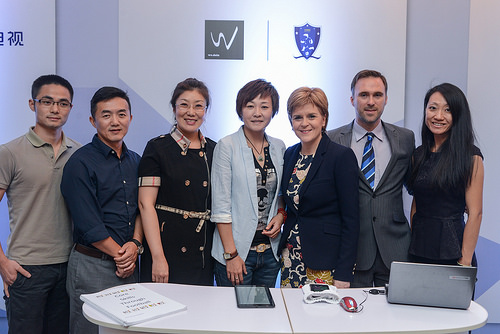<image>
Is there a women behind the table? Yes. From this viewpoint, the women is positioned behind the table, with the table partially or fully occluding the women. Where is the woman in relation to the man? Is it behind the man? No. The woman is not behind the man. From this viewpoint, the woman appears to be positioned elsewhere in the scene. Where is the laptop in relation to the wall? Is it on the wall? No. The laptop is not positioned on the wall. They may be near each other, but the laptop is not supported by or resting on top of the wall. 